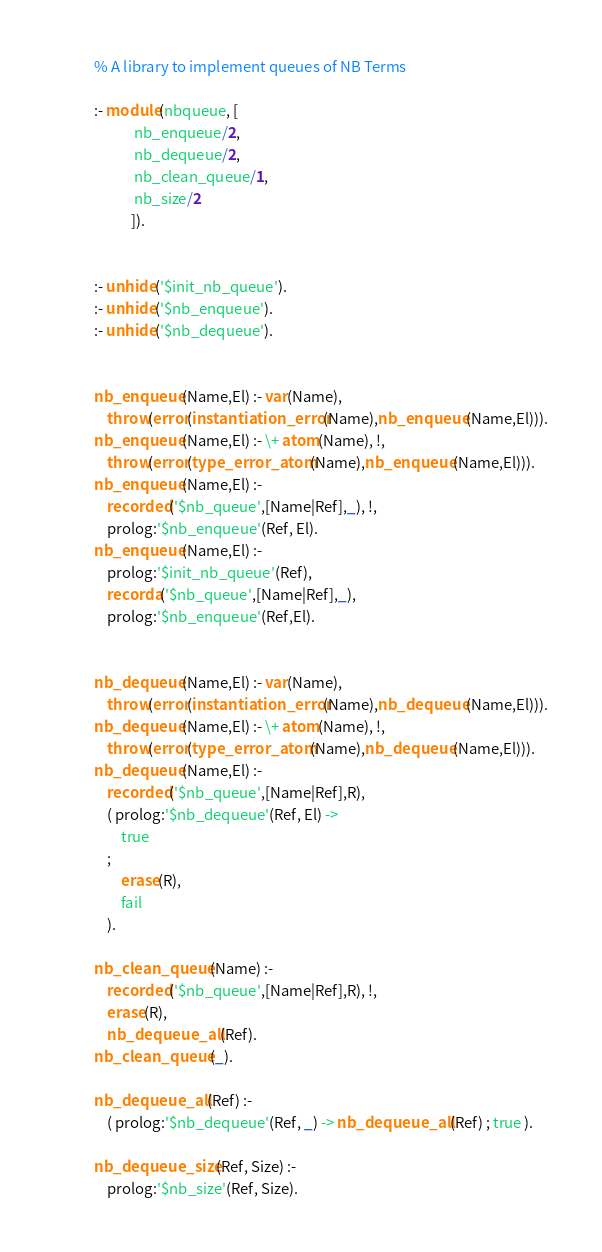Convert code to text. <code><loc_0><loc_0><loc_500><loc_500><_Prolog_>% A library to implement queues of NB Terms

:- module(nbqueue, [
		    nb_enqueue/2,
		    nb_dequeue/2,
		    nb_clean_queue/1,	  
		    nb_size/2	  
		   ]).


:- unhide('$init_nb_queue').
:- unhide('$nb_enqueue').
:- unhide('$nb_dequeue').


nb_enqueue(Name,El) :- var(Name),
	throw(error(instantiation_error(Name),nb_enqueue(Name,El))).
nb_enqueue(Name,El) :- \+ atom(Name), !,
	throw(error(type_error_atom(Name),nb_enqueue(Name,El))).
nb_enqueue(Name,El) :-
	recorded('$nb_queue',[Name|Ref],_), !,
	prolog:'$nb_enqueue'(Ref, El).
nb_enqueue(Name,El) :-
	prolog:'$init_nb_queue'(Ref),
	recorda('$nb_queue',[Name|Ref],_),
	prolog:'$nb_enqueue'(Ref,El).


nb_dequeue(Name,El) :- var(Name),
	throw(error(instantiation_error(Name),nb_dequeue(Name,El))).
nb_dequeue(Name,El) :- \+ atom(Name), !,
	throw(error(type_error_atom(Name),nb_dequeue(Name,El))).
nb_dequeue(Name,El) :-
	recorded('$nb_queue',[Name|Ref],R),
	( prolog:'$nb_dequeue'(Ref, El) ->
	    true
	;
	    erase(R),
	    fail
	).

nb_clean_queue(Name) :-
	recorded('$nb_queue',[Name|Ref],R), !,
	erase(R),
	nb_dequeue_all(Ref).
nb_clean_queue(_).

nb_dequeue_all(Ref) :-
	( prolog:'$nb_dequeue'(Ref, _) -> nb_dequeue_all(Ref) ; true ).

nb_dequeue_size(Ref, Size) :-
	prolog:'$nb_size'(Ref, Size).
</code> 